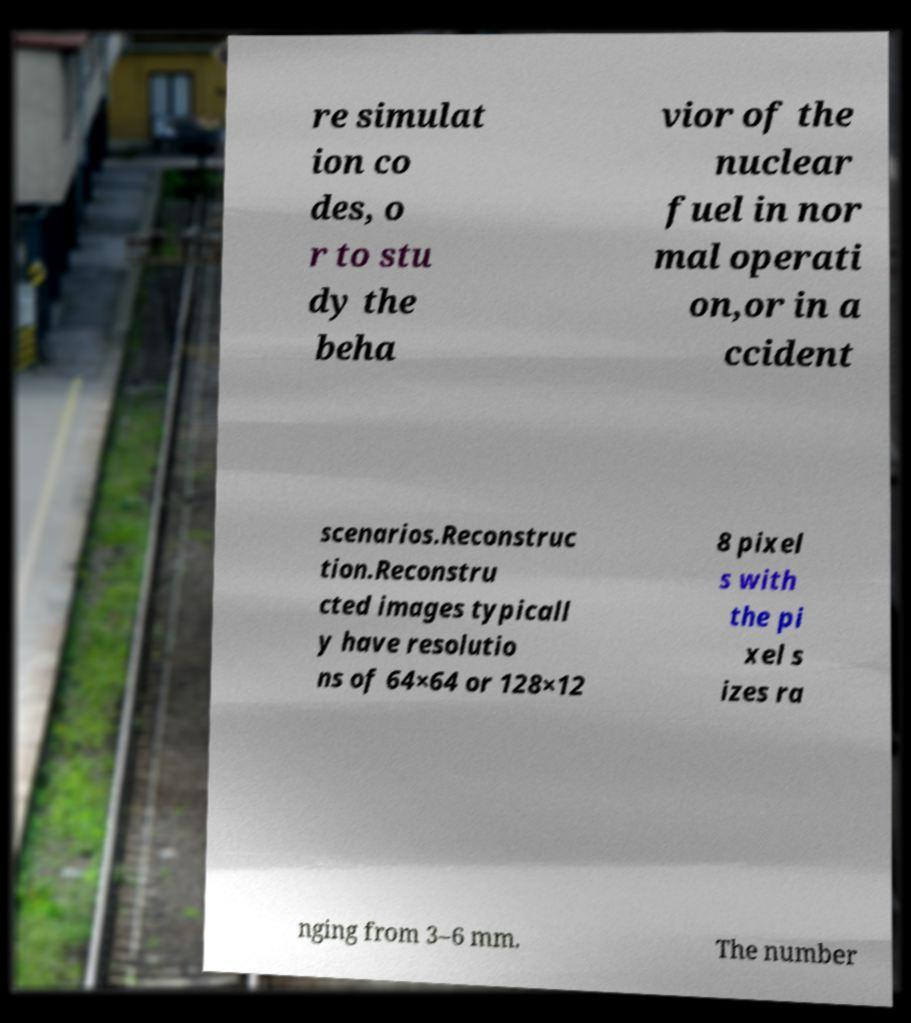Could you extract and type out the text from this image? re simulat ion co des, o r to stu dy the beha vior of the nuclear fuel in nor mal operati on,or in a ccident scenarios.Reconstruc tion.Reconstru cted images typicall y have resolutio ns of 64×64 or 128×12 8 pixel s with the pi xel s izes ra nging from 3–6 mm. The number 